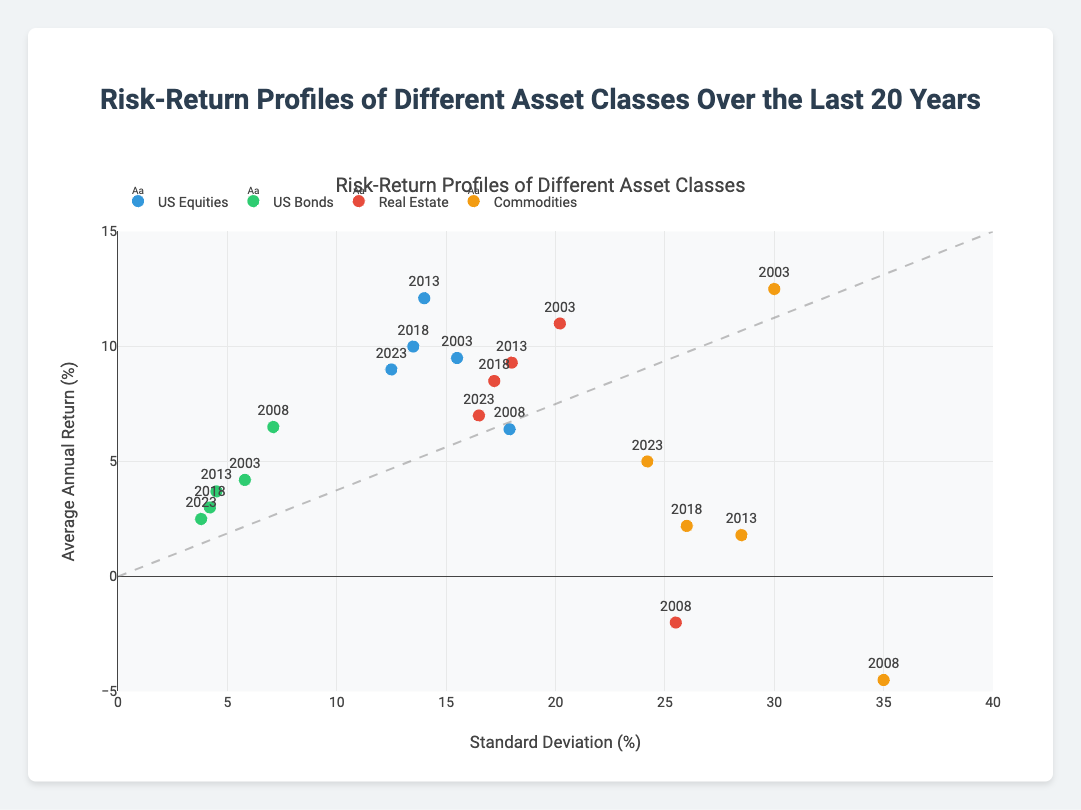What is the title of the scatter plot? The title is usually displayed at the top of the figure and provides an overview of what the graph represents. Here, the title is "Risk-Return Profiles of Different Asset Classes Over the Last 20 Years."
Answer: Risk-Return Profiles of Different Asset Classes Over the Last 20 Years Which axis represents the Standard Deviation (%)? The x-axis represents the standard deviation because it is labeled "Standard Deviation (%)".
Answer: x-axis Which asset class has the highest average annual return in 2003? In the plot, by locating the point for the year 2003, and comparing the y-axis values (which represent the average annual return) for each asset class, "Commodities" has the highest average annual return at 12.5%.
Answer: Commodities What is the trend line suggesting about the relationship between risk and return? A trend line typically indicates the general direction of the data. In this scatter plot, the trend line likely slopes upward, showing a positive correlation between risk (standard deviation) and return (annual return). The relationship suggests that higher risk is associated with higher potential returns.
Answer: Higher risk, higher potential returns How has the average annual return for US Equities changed from 2008 to 2013? To find this, locate the points for US Equities in 2008 and 2013. In 2008, the average annual return was 6.4%, and in 2013 it was 12.1%, showing an increase.
Answer: Increased from 6.4% to 12.1% Which asset class has the lowest standard deviation in 2023? By observing the 2023 data points and comparing each asset class's standard deviation (x-axis values), "US Bonds" has the lowest standard deviation at 3.8%.
Answer: US Bonds Compare the risk-return profiles of Real Estate and Commodities in 2008. In 2008, Real Estate had an average annual return of -2.0% with a standard deviation of 25.5%, while Commodities had an average annual return of -4.5% with a standard deviation of 35.0%. Real Estate had a less negative return but a lower risk compared to Commodities.
Answer: Real Estate had a less negative return and lower risk than Commodities Which asset class showed a decreasing trend in both average annual return and standard deviation from 2003 to 2023? By tracking the data for each asset class from 2003 to 2023, we see "US Bonds" shows a decreasing trend in both its average annual return (4.2% to 2.5%) and standard deviation (5.8% to 3.8%).
Answer: US Bonds What was the average annual return difference between US Equities and Real Estate in 2013? In 2013, US Equities had an average annual return of 12.1%, and Real Estate had 9.3%. The difference is calculated as 12.1% - 9.3% = 2.8%.
Answer: 2.8% Which asset class had the most volatile performance over the last 20 years? Volatility is indicated by the highest standard deviation. By comparing standard deviations, "Commodities" has the highest values, reaching up to 35.0% in 2008, indicating it was the most volatile asset class.
Answer: Commodities 